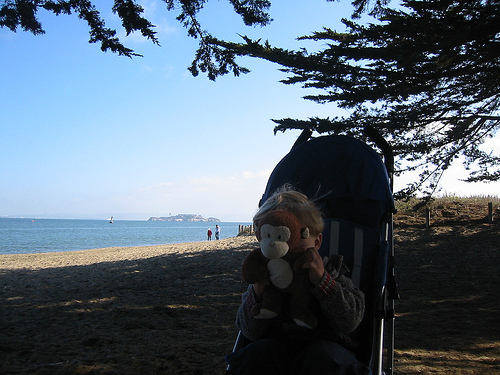<image>
Is there a tree on the stroller? No. The tree is not positioned on the stroller. They may be near each other, but the tree is not supported by or resting on top of the stroller. 